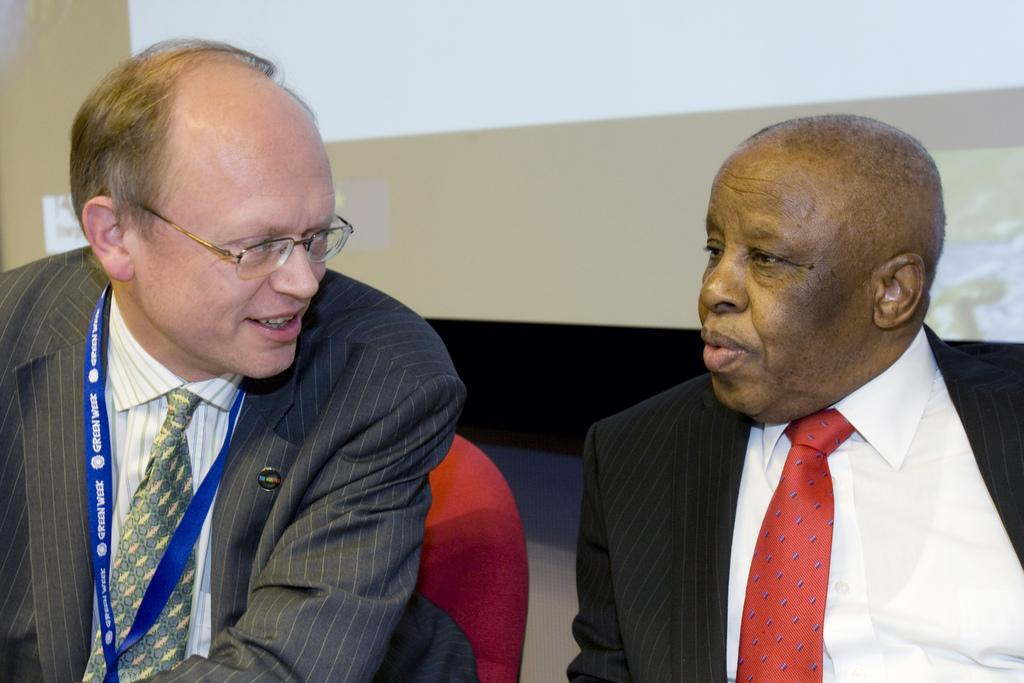How many people are in the image? There are two men in the image. What is the position of the man on the left side? The man on the left side is sitting on a chair. What can be seen in the background of the image? There is a screen and a wall in the background of the image. What type of bread and jam can be seen on the table in the image? There is no bread or jam present in the image; it only features two men and a background with a screen and a wall. 